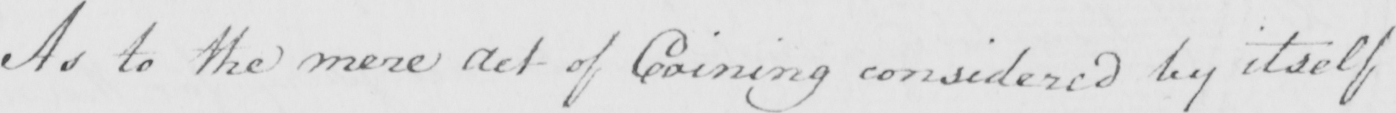Please provide the text content of this handwritten line. As to the mere Act of Coining considered by itself 